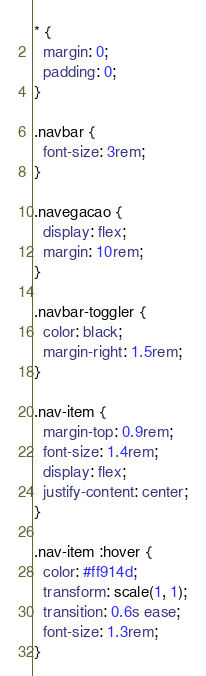Convert code to text. <code><loc_0><loc_0><loc_500><loc_500><_CSS_>* {
  margin: 0;
  padding: 0;
}

.navbar {
  font-size: 3rem;
}

.navegacao {
  display: flex;
  margin: 10rem;
}

.navbar-toggler {
  color: black;
  margin-right: 1.5rem;
}

.nav-item {
  margin-top: 0.9rem;
  font-size: 1.4rem;
  display: flex;
  justify-content: center;
}

.nav-item :hover {
  color: #ff914d;
  transform: scale(1, 1);
  transition: 0.6s ease;
  font-size: 1.3rem;
}
</code> 